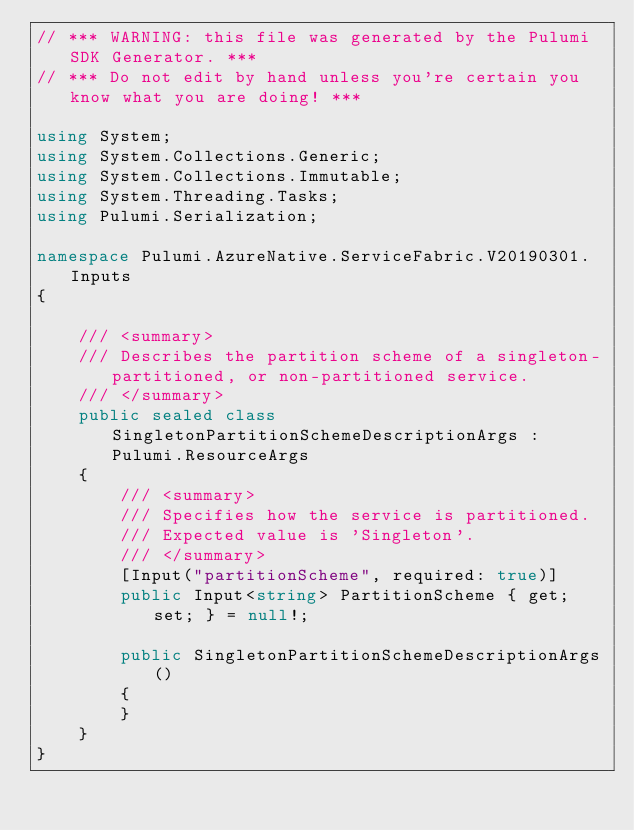<code> <loc_0><loc_0><loc_500><loc_500><_C#_>// *** WARNING: this file was generated by the Pulumi SDK Generator. ***
// *** Do not edit by hand unless you're certain you know what you are doing! ***

using System;
using System.Collections.Generic;
using System.Collections.Immutable;
using System.Threading.Tasks;
using Pulumi.Serialization;

namespace Pulumi.AzureNative.ServiceFabric.V20190301.Inputs
{

    /// <summary>
    /// Describes the partition scheme of a singleton-partitioned, or non-partitioned service.
    /// </summary>
    public sealed class SingletonPartitionSchemeDescriptionArgs : Pulumi.ResourceArgs
    {
        /// <summary>
        /// Specifies how the service is partitioned.
        /// Expected value is 'Singleton'.
        /// </summary>
        [Input("partitionScheme", required: true)]
        public Input<string> PartitionScheme { get; set; } = null!;

        public SingletonPartitionSchemeDescriptionArgs()
        {
        }
    }
}
</code> 